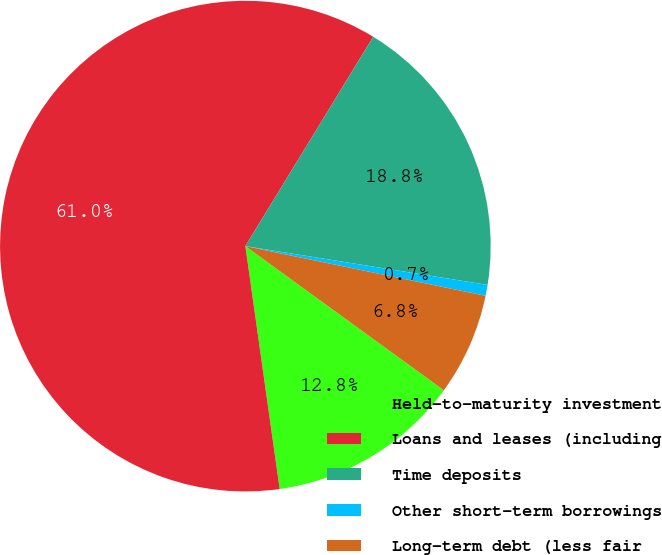Convert chart to OTSL. <chart><loc_0><loc_0><loc_500><loc_500><pie_chart><fcel>Held-to-maturity investment<fcel>Loans and leases (including<fcel>Time deposits<fcel>Other short-term borrowings<fcel>Long-term debt (less fair<nl><fcel>12.77%<fcel>60.96%<fcel>18.8%<fcel>0.72%<fcel>6.75%<nl></chart> 